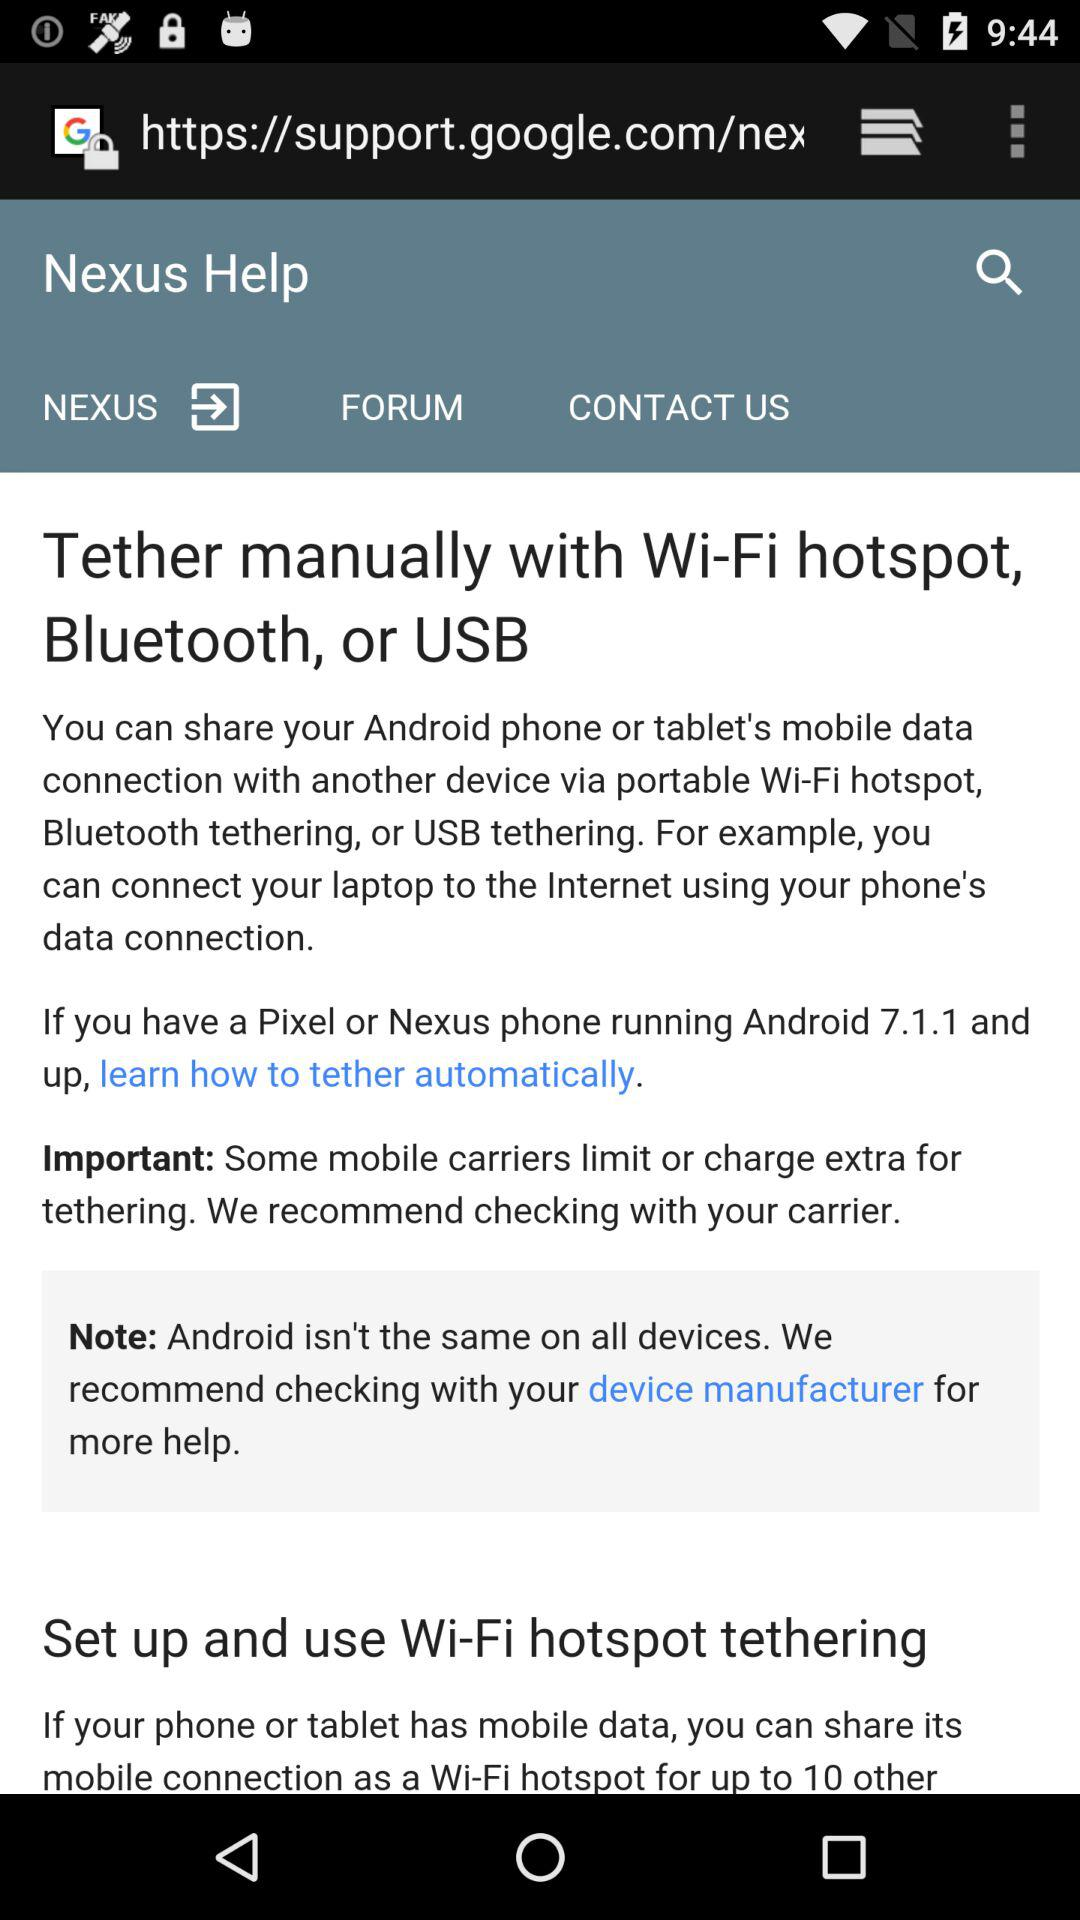What is the Android version number? The Android version number is 7.1.1. 